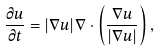<formula> <loc_0><loc_0><loc_500><loc_500>\frac { \partial u } { \partial t } = | \nabla u | \nabla \cdot \left ( \frac { \nabla u } { | \nabla u | } \right ) ,</formula> 